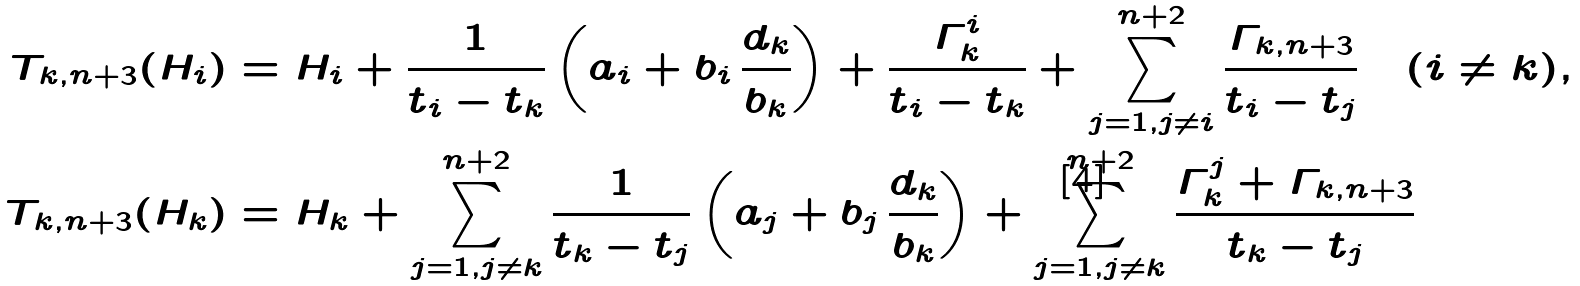<formula> <loc_0><loc_0><loc_500><loc_500>T _ { k , n + 3 } ( H _ { i } ) & = H _ { i } + \frac { 1 } { t _ { i } - t _ { k } } \left ( a _ { i } + b _ { i } \, \frac { d _ { k } } { b _ { k } } \right ) + \frac { \varGamma ^ { i } _ { k } } { t _ { i } - t _ { k } } + \sum _ { j = 1 , j \neq i } ^ { n + 2 } \frac { \varGamma _ { k , n + 3 } } { t _ { i } - t _ { j } } \quad ( i \neq k ) , \\ T _ { k , n + 3 } ( H _ { k } ) & = H _ { k } + \sum _ { j = 1 , j \neq k } ^ { n + 2 } \frac { 1 } { t _ { k } - t _ { j } } \left ( a _ { j } + b _ { j } \, \frac { d _ { k } } { b _ { k } } \right ) + \sum _ { j = 1 , j \neq k } ^ { n + 2 } \frac { \varGamma ^ { j } _ { k } + \varGamma _ { k , n + 3 } } { t _ { k } - t _ { j } }</formula> 